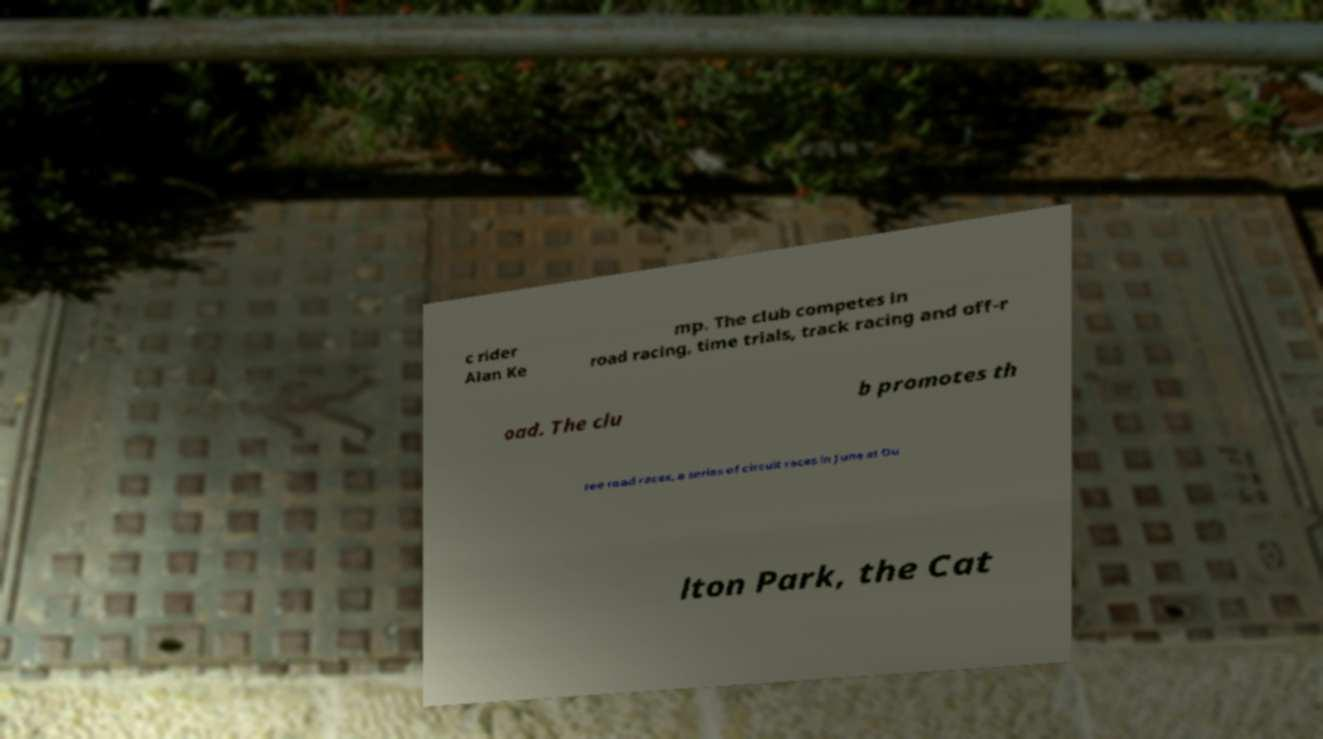What messages or text are displayed in this image? I need them in a readable, typed format. c rider Alan Ke mp. The club competes in road racing, time trials, track racing and off-r oad. The clu b promotes th ree road races, a series of circuit races in June at Ou lton Park, the Cat 